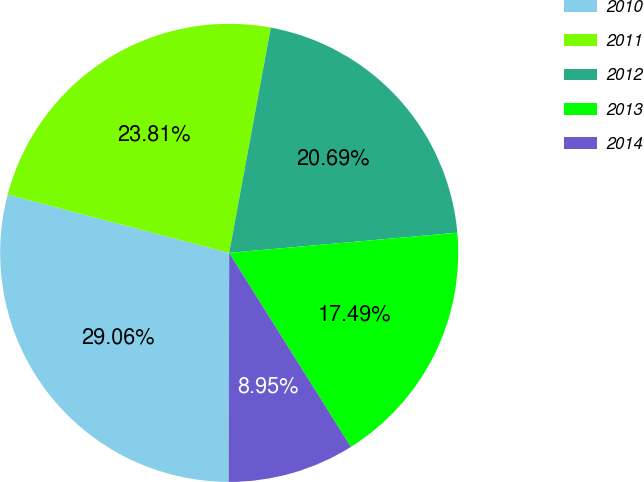Convert chart. <chart><loc_0><loc_0><loc_500><loc_500><pie_chart><fcel>2010<fcel>2011<fcel>2012<fcel>2013<fcel>2014<nl><fcel>29.06%<fcel>23.81%<fcel>20.69%<fcel>17.49%<fcel>8.95%<nl></chart> 